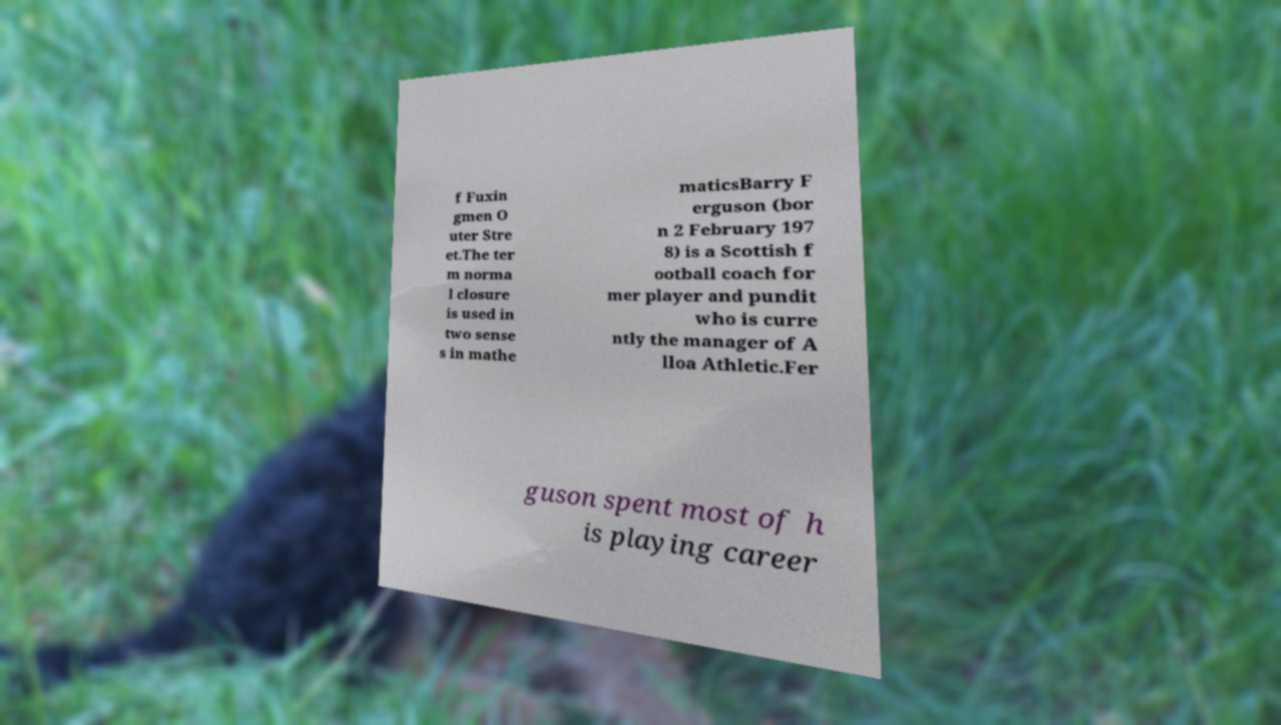Could you assist in decoding the text presented in this image and type it out clearly? f Fuxin gmen O uter Stre et.The ter m norma l closure is used in two sense s in mathe maticsBarry F erguson (bor n 2 February 197 8) is a Scottish f ootball coach for mer player and pundit who is curre ntly the manager of A lloa Athletic.Fer guson spent most of h is playing career 